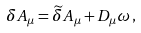Convert formula to latex. <formula><loc_0><loc_0><loc_500><loc_500>\delta A _ { \mu } = \widetilde { \delta } A _ { \mu } + D _ { \mu } \omega \, ,</formula> 